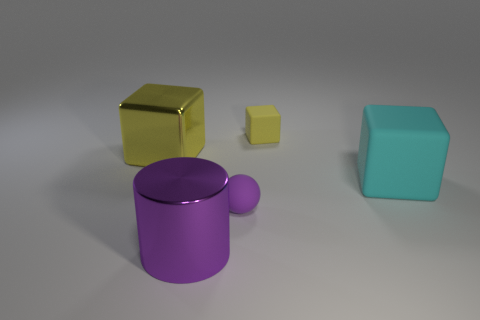What is the tiny object right of the tiny purple sphere made of?
Offer a very short reply. Rubber. There is another cube that is the same color as the metallic cube; what is it made of?
Ensure brevity in your answer.  Rubber. How many big objects are either rubber cubes or cyan matte objects?
Your response must be concise. 1. The sphere is what color?
Offer a terse response. Purple. There is a large metallic object that is right of the big yellow metal object; are there any large purple metallic objects to the right of it?
Make the answer very short. No. Is the number of small blocks on the right side of the yellow rubber object less than the number of brown metallic cubes?
Your response must be concise. No. Is the material of the yellow object that is right of the big metallic cube the same as the large yellow thing?
Your answer should be compact. No. What is the color of the tiny thing that is made of the same material as the small block?
Offer a very short reply. Purple. Is the number of big yellow shiny things behind the yellow matte thing less than the number of purple metal cylinders right of the big yellow object?
Ensure brevity in your answer.  Yes. There is a object behind the big yellow object; is it the same color as the metal thing that is behind the matte sphere?
Provide a short and direct response. Yes. 